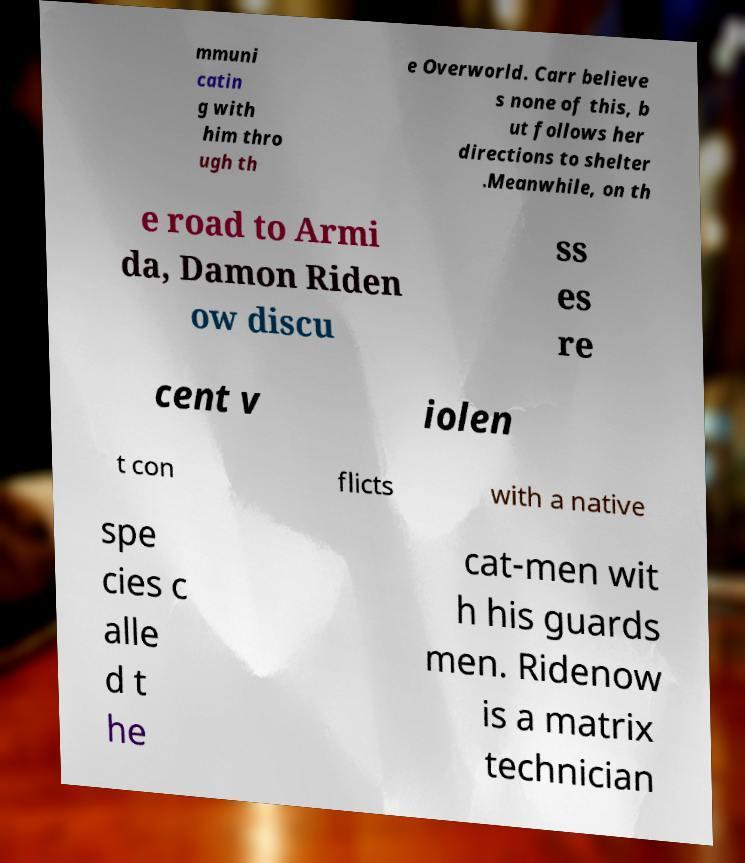For documentation purposes, I need the text within this image transcribed. Could you provide that? mmuni catin g with him thro ugh th e Overworld. Carr believe s none of this, b ut follows her directions to shelter .Meanwhile, on th e road to Armi da, Damon Riden ow discu ss es re cent v iolen t con flicts with a native spe cies c alle d t he cat-men wit h his guards men. Ridenow is a matrix technician 